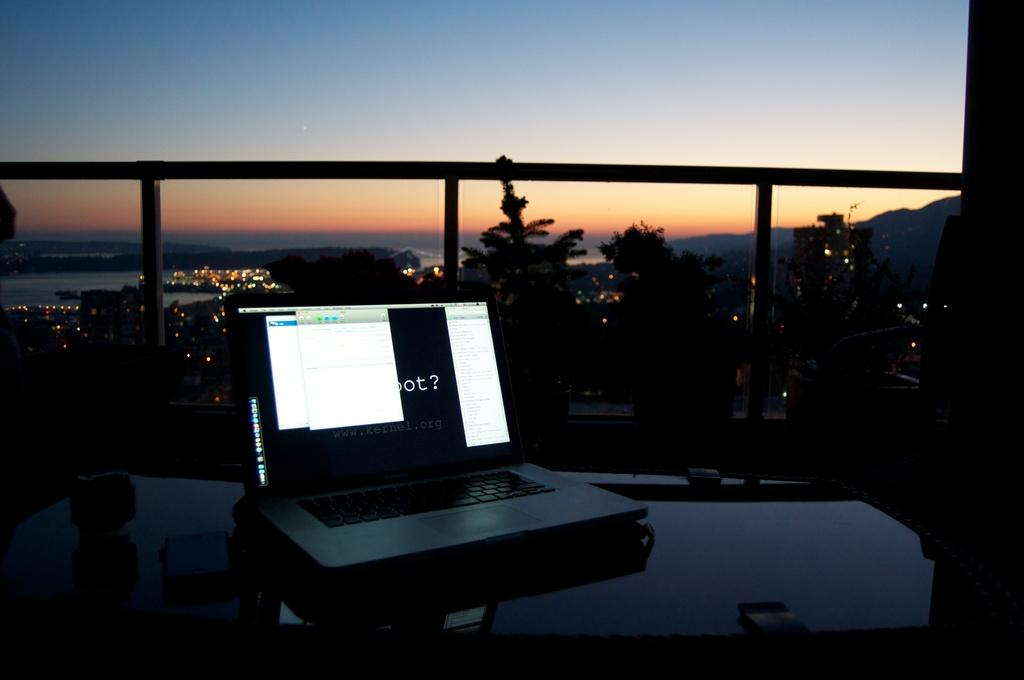<image>
Summarize the visual content of the image. A laptop asking a question as it sits on a table on a balcony. 